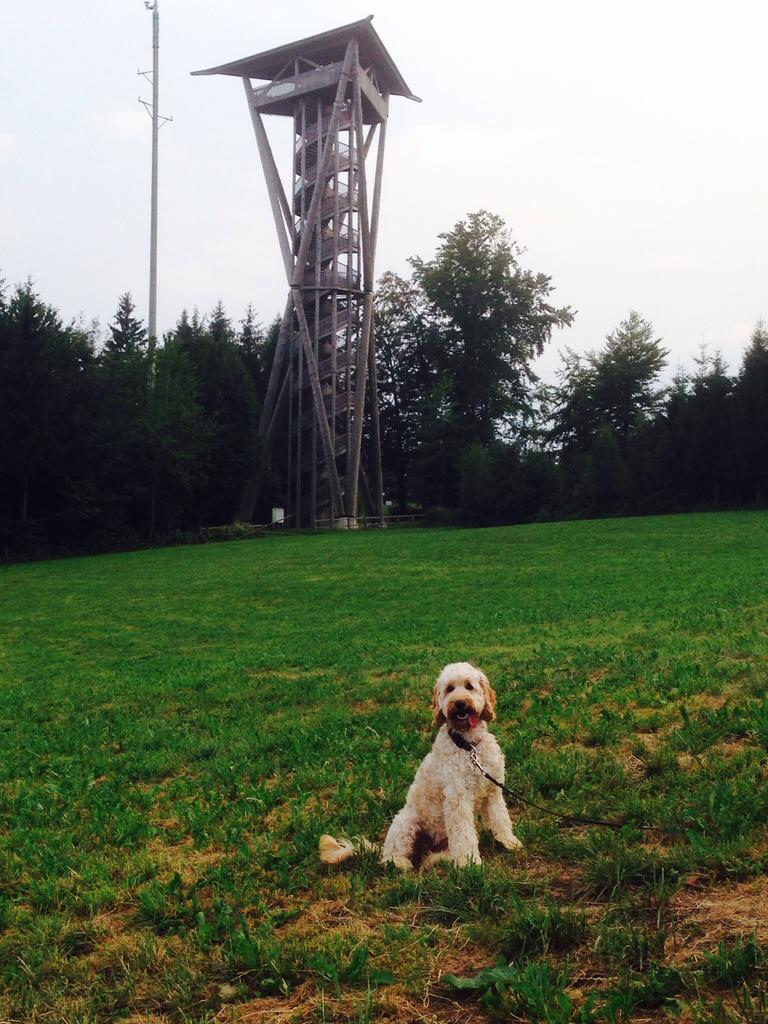Could you give a brief overview of what you see in this image? In this picture I can see a dog at the bottom, in the middle it looks like an iron frame and there are trees. At the top there is the sky. 